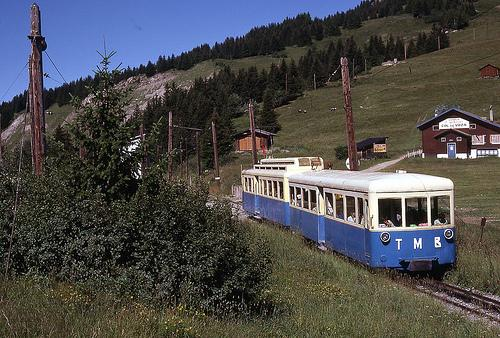In one sentence, describe the atmosphere of the image. The image depicts a peaceful and scenic view of a train passing through a countryside landscape with trees and a wooden pole. Mention two natural elements and one man-made object from the image. Trees on the hill, bushes around a post, and a passenger train on tracks. Provide a brief overview of the scene, focusing on its most important elements. The scene features a train with multiple windows passing by trees on the hill and a tall wooden pole, providing a serene countryside view. What is the main transportation mode shown in the image and the environment around it? The main transportation mode is a train on tracks, and it is surrounded by trees, bushes, and a wooden pole. Tell me three distinctive features you see in the image. A passenger train on tracks, trees on the hill, and multiple windows on the train. Give a brief description of the primary scene in the image. A passenger train is on the tracks with several windows, surrounded by trees, a post, and a wooden pole. Describe the image focusing on the train and its surroundings. A train with multiple windows runs on tracks, and is surrounded by trees on the hill, a post behind bushes, and a tall wooden pole nearby. 